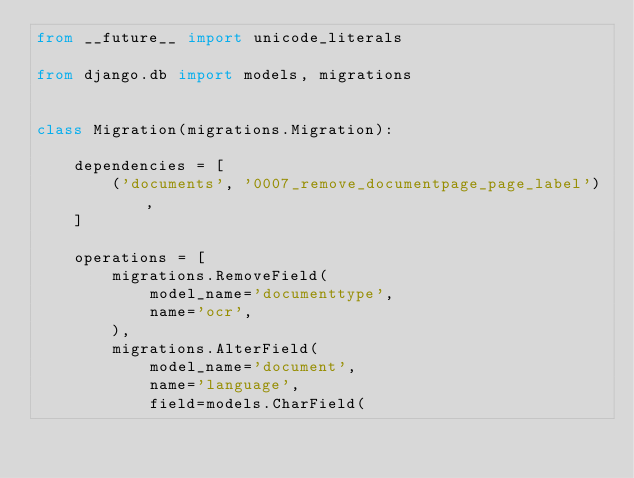Convert code to text. <code><loc_0><loc_0><loc_500><loc_500><_Python_>from __future__ import unicode_literals

from django.db import models, migrations


class Migration(migrations.Migration):

    dependencies = [
        ('documents', '0007_remove_documentpage_page_label'),
    ]

    operations = [
        migrations.RemoveField(
            model_name='documenttype',
            name='ocr',
        ),
        migrations.AlterField(
            model_name='document',
            name='language',
            field=models.CharField(</code> 